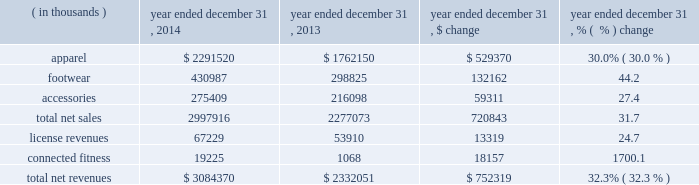Other expense , net increased $ 0.8 million to $ 7.2 million in 2015 from $ 6.4 million in 2014 .
This increase was due to higher net losses on the combined foreign currency exchange rate changes on transactions denominated in foreign currencies and our foreign currency derivative financial instruments in 2015 .
Provision for income taxes increased $ 19.9 million to $ 154.1 million in 2015 from $ 134.2 million in 2014 .
Our effective tax rate was 39.9% ( 39.9 % ) in 2015 compared to 39.2% ( 39.2 % ) in 2014 .
Our effective tax rate for 2015 was higher than the effective tax rate for 2014 primarily due to increased non-deductible costs incurred in connection with our connected fitness acquisitions in 2015 .
Year ended december 31 , 2014 compared to year ended december 31 , 2013 net revenues increased $ 752.3 million , or 32.3% ( 32.3 % ) , to $ 3084.4 million in 2014 from $ 2332.1 million in 2013 .
Net revenues by product category are summarized below: .
The increase in net sales were driven primarily by : 2022 apparel unit sales growth and new offerings in multiple lines led by training , hunt and golf ; and 2022 footwear unit sales growth , led by running and basketball .
License revenues increased $ 13.3 million , or 24.7% ( 24.7 % ) , to $ 67.2 million in 2014 from $ 53.9 million in 2013 .
This increase in license revenues was primarily a result of increased distribution and continued unit volume growth by our licensees .
Connected fitness revenue increased $ 18.1 million to $ 19.2 million in 2014 from $ 1.1 million in 2013 primarily due to a full year of revenue from our connected fitness business in 2014 compared to one month in gross profit increased $ 375.5 million to $ 1512.2 million in 2014 from $ 1136.7 million in 2013 .
Gross profit as a percentage of net revenues , or gross margin , increased 30 basis points to 49.0% ( 49.0 % ) in 2014 compared to 48.7% ( 48.7 % ) in 2013 .
The increase in gross margin percentage was primarily driven by the following : 2022 approximate 20 basis point increase driven primarily by decreased sales mix of excess inventory through our factory house outlet stores ; and 2022 approximate 20 basis point increase as a result of higher duty costs recorded during the prior year on certain products imported in previous years .
The above increases were partially offset by : 2022 approximate 10 basis point decrease by unfavorable foreign currency exchange rate fluctuations. .
In 2014 what was the percent of the sales revenues of apparel to the total revenues? 
Rationale: in 2014 74.3% of the total revenues was made of sales revenues of apparel
Computations: (2291520 / 3084370)
Answer: 0.74295. 